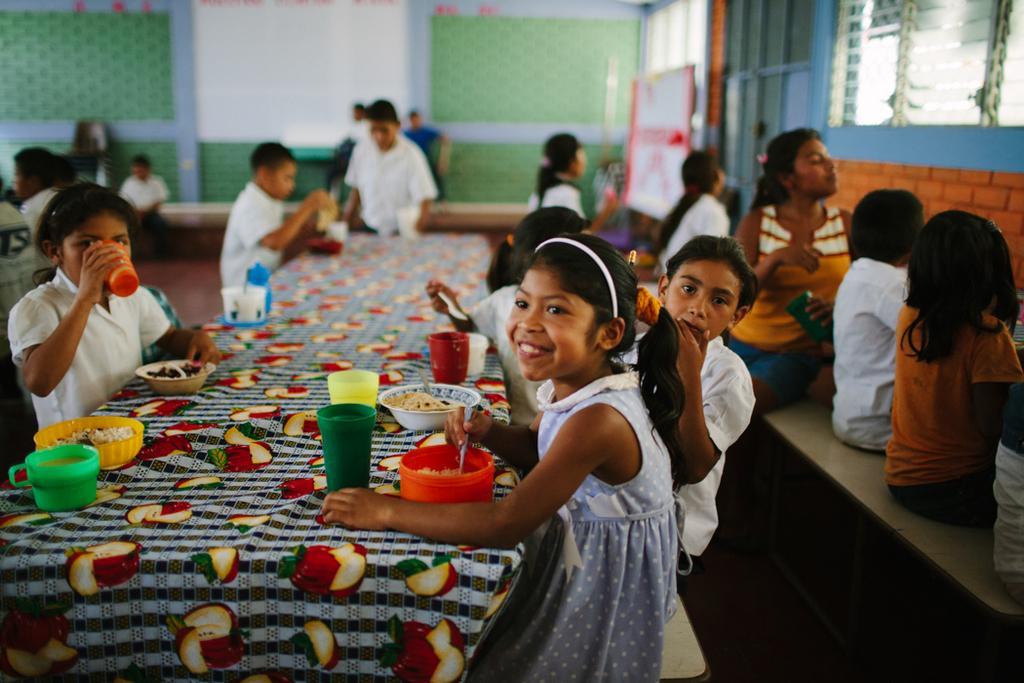How would you summarize this image in a sentence or two? In this given picture there are children sitting in front of a table,, on the bench and eating some food. On the table there are some glasses, bowls and cloth were placed. In the background, there are some children sitting and standing. We can observe a wall here. 